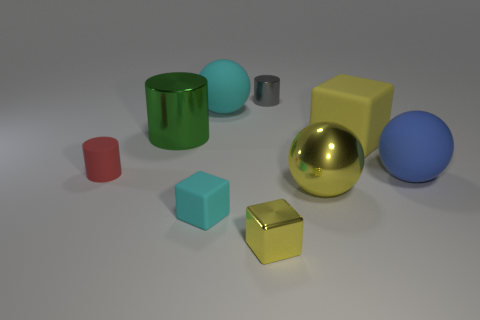The image shows various objects with different textures. Can you describe the textures that appear in this image? Certainly! The image presents a diverse range of textures. The yellow sphere on the right has a reflective, shiny surface that mirrors its surroundings, likely a metallic texture. The large yellow cube appears matte and slightly bumpy, resembling a rubbery texture. The green cylinder shows a reflective pattern indicative of a metallic or plastic material, while the smaller red cup has a matte, possibly plastic finish. The cyan-colored cube exhibits a smooth, possibly plastic surface as well, and the small silver cylinder has a brushed metallic texture. Finally, the large blue sphere seems to have a uniform matte finish, possibly indicative of a painted or plastic surface. 